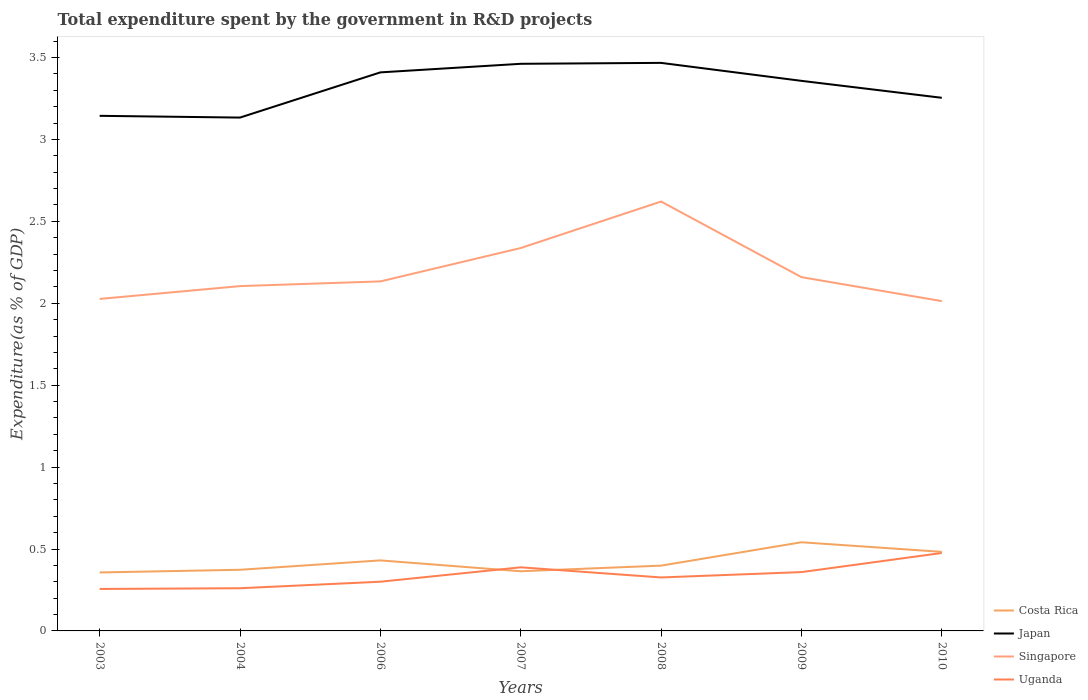How many different coloured lines are there?
Make the answer very short. 4. Does the line corresponding to Costa Rica intersect with the line corresponding to Uganda?
Provide a succinct answer. Yes. Across all years, what is the maximum total expenditure spent by the government in R&D projects in Singapore?
Your answer should be compact. 2.01. What is the total total expenditure spent by the government in R&D projects in Uganda in the graph?
Keep it short and to the point. -0.09. What is the difference between the highest and the second highest total expenditure spent by the government in R&D projects in Singapore?
Offer a very short reply. 0.61. What is the difference between the highest and the lowest total expenditure spent by the government in R&D projects in Costa Rica?
Your answer should be compact. 3. How many lines are there?
Provide a short and direct response. 4. How many years are there in the graph?
Your answer should be compact. 7. What is the difference between two consecutive major ticks on the Y-axis?
Provide a short and direct response. 0.5. Does the graph contain any zero values?
Your response must be concise. No. Where does the legend appear in the graph?
Keep it short and to the point. Bottom right. How are the legend labels stacked?
Provide a succinct answer. Vertical. What is the title of the graph?
Your answer should be very brief. Total expenditure spent by the government in R&D projects. Does "South Africa" appear as one of the legend labels in the graph?
Make the answer very short. No. What is the label or title of the X-axis?
Provide a succinct answer. Years. What is the label or title of the Y-axis?
Your response must be concise. Expenditure(as % of GDP). What is the Expenditure(as % of GDP) in Costa Rica in 2003?
Offer a very short reply. 0.36. What is the Expenditure(as % of GDP) of Japan in 2003?
Provide a succinct answer. 3.14. What is the Expenditure(as % of GDP) in Singapore in 2003?
Your answer should be compact. 2.03. What is the Expenditure(as % of GDP) in Uganda in 2003?
Your response must be concise. 0.26. What is the Expenditure(as % of GDP) in Costa Rica in 2004?
Your response must be concise. 0.37. What is the Expenditure(as % of GDP) of Japan in 2004?
Make the answer very short. 3.13. What is the Expenditure(as % of GDP) of Singapore in 2004?
Make the answer very short. 2.1. What is the Expenditure(as % of GDP) of Uganda in 2004?
Offer a terse response. 0.26. What is the Expenditure(as % of GDP) of Costa Rica in 2006?
Provide a short and direct response. 0.43. What is the Expenditure(as % of GDP) of Japan in 2006?
Offer a very short reply. 3.41. What is the Expenditure(as % of GDP) in Singapore in 2006?
Your answer should be very brief. 2.13. What is the Expenditure(as % of GDP) in Uganda in 2006?
Your response must be concise. 0.3. What is the Expenditure(as % of GDP) in Costa Rica in 2007?
Give a very brief answer. 0.36. What is the Expenditure(as % of GDP) in Japan in 2007?
Provide a succinct answer. 3.46. What is the Expenditure(as % of GDP) in Singapore in 2007?
Your answer should be compact. 2.34. What is the Expenditure(as % of GDP) of Uganda in 2007?
Your answer should be very brief. 0.39. What is the Expenditure(as % of GDP) of Costa Rica in 2008?
Keep it short and to the point. 0.4. What is the Expenditure(as % of GDP) of Japan in 2008?
Make the answer very short. 3.47. What is the Expenditure(as % of GDP) in Singapore in 2008?
Offer a terse response. 2.62. What is the Expenditure(as % of GDP) of Uganda in 2008?
Offer a terse response. 0.33. What is the Expenditure(as % of GDP) of Costa Rica in 2009?
Ensure brevity in your answer.  0.54. What is the Expenditure(as % of GDP) of Japan in 2009?
Your answer should be compact. 3.36. What is the Expenditure(as % of GDP) of Singapore in 2009?
Ensure brevity in your answer.  2.16. What is the Expenditure(as % of GDP) in Uganda in 2009?
Your answer should be compact. 0.36. What is the Expenditure(as % of GDP) in Costa Rica in 2010?
Give a very brief answer. 0.48. What is the Expenditure(as % of GDP) in Japan in 2010?
Offer a terse response. 3.25. What is the Expenditure(as % of GDP) in Singapore in 2010?
Offer a terse response. 2.01. What is the Expenditure(as % of GDP) in Uganda in 2010?
Your answer should be compact. 0.48. Across all years, what is the maximum Expenditure(as % of GDP) in Costa Rica?
Keep it short and to the point. 0.54. Across all years, what is the maximum Expenditure(as % of GDP) of Japan?
Give a very brief answer. 3.47. Across all years, what is the maximum Expenditure(as % of GDP) of Singapore?
Keep it short and to the point. 2.62. Across all years, what is the maximum Expenditure(as % of GDP) of Uganda?
Make the answer very short. 0.48. Across all years, what is the minimum Expenditure(as % of GDP) in Costa Rica?
Make the answer very short. 0.36. Across all years, what is the minimum Expenditure(as % of GDP) of Japan?
Ensure brevity in your answer.  3.13. Across all years, what is the minimum Expenditure(as % of GDP) of Singapore?
Your answer should be very brief. 2.01. Across all years, what is the minimum Expenditure(as % of GDP) in Uganda?
Provide a succinct answer. 0.26. What is the total Expenditure(as % of GDP) in Costa Rica in the graph?
Ensure brevity in your answer.  2.95. What is the total Expenditure(as % of GDP) of Japan in the graph?
Your answer should be compact. 23.23. What is the total Expenditure(as % of GDP) of Singapore in the graph?
Ensure brevity in your answer.  15.39. What is the total Expenditure(as % of GDP) of Uganda in the graph?
Your answer should be very brief. 2.37. What is the difference between the Expenditure(as % of GDP) of Costa Rica in 2003 and that in 2004?
Provide a succinct answer. -0.02. What is the difference between the Expenditure(as % of GDP) in Japan in 2003 and that in 2004?
Offer a terse response. 0.01. What is the difference between the Expenditure(as % of GDP) in Singapore in 2003 and that in 2004?
Give a very brief answer. -0.08. What is the difference between the Expenditure(as % of GDP) of Uganda in 2003 and that in 2004?
Ensure brevity in your answer.  -0. What is the difference between the Expenditure(as % of GDP) of Costa Rica in 2003 and that in 2006?
Provide a short and direct response. -0.07. What is the difference between the Expenditure(as % of GDP) of Japan in 2003 and that in 2006?
Provide a short and direct response. -0.27. What is the difference between the Expenditure(as % of GDP) of Singapore in 2003 and that in 2006?
Provide a succinct answer. -0.11. What is the difference between the Expenditure(as % of GDP) of Uganda in 2003 and that in 2006?
Make the answer very short. -0.04. What is the difference between the Expenditure(as % of GDP) of Costa Rica in 2003 and that in 2007?
Provide a short and direct response. -0.01. What is the difference between the Expenditure(as % of GDP) in Japan in 2003 and that in 2007?
Your response must be concise. -0.32. What is the difference between the Expenditure(as % of GDP) of Singapore in 2003 and that in 2007?
Your answer should be very brief. -0.31. What is the difference between the Expenditure(as % of GDP) of Uganda in 2003 and that in 2007?
Give a very brief answer. -0.13. What is the difference between the Expenditure(as % of GDP) in Costa Rica in 2003 and that in 2008?
Provide a short and direct response. -0.04. What is the difference between the Expenditure(as % of GDP) of Japan in 2003 and that in 2008?
Your answer should be very brief. -0.32. What is the difference between the Expenditure(as % of GDP) in Singapore in 2003 and that in 2008?
Your answer should be very brief. -0.59. What is the difference between the Expenditure(as % of GDP) of Uganda in 2003 and that in 2008?
Your response must be concise. -0.07. What is the difference between the Expenditure(as % of GDP) of Costa Rica in 2003 and that in 2009?
Your answer should be compact. -0.18. What is the difference between the Expenditure(as % of GDP) of Japan in 2003 and that in 2009?
Provide a succinct answer. -0.21. What is the difference between the Expenditure(as % of GDP) of Singapore in 2003 and that in 2009?
Offer a terse response. -0.13. What is the difference between the Expenditure(as % of GDP) in Uganda in 2003 and that in 2009?
Make the answer very short. -0.1. What is the difference between the Expenditure(as % of GDP) in Costa Rica in 2003 and that in 2010?
Ensure brevity in your answer.  -0.13. What is the difference between the Expenditure(as % of GDP) in Japan in 2003 and that in 2010?
Offer a terse response. -0.11. What is the difference between the Expenditure(as % of GDP) of Singapore in 2003 and that in 2010?
Ensure brevity in your answer.  0.01. What is the difference between the Expenditure(as % of GDP) of Uganda in 2003 and that in 2010?
Keep it short and to the point. -0.22. What is the difference between the Expenditure(as % of GDP) in Costa Rica in 2004 and that in 2006?
Your answer should be very brief. -0.06. What is the difference between the Expenditure(as % of GDP) in Japan in 2004 and that in 2006?
Make the answer very short. -0.28. What is the difference between the Expenditure(as % of GDP) in Singapore in 2004 and that in 2006?
Your answer should be compact. -0.03. What is the difference between the Expenditure(as % of GDP) of Uganda in 2004 and that in 2006?
Your answer should be very brief. -0.04. What is the difference between the Expenditure(as % of GDP) in Costa Rica in 2004 and that in 2007?
Keep it short and to the point. 0.01. What is the difference between the Expenditure(as % of GDP) in Japan in 2004 and that in 2007?
Your answer should be compact. -0.33. What is the difference between the Expenditure(as % of GDP) of Singapore in 2004 and that in 2007?
Ensure brevity in your answer.  -0.23. What is the difference between the Expenditure(as % of GDP) of Uganda in 2004 and that in 2007?
Keep it short and to the point. -0.13. What is the difference between the Expenditure(as % of GDP) in Costa Rica in 2004 and that in 2008?
Provide a succinct answer. -0.03. What is the difference between the Expenditure(as % of GDP) of Japan in 2004 and that in 2008?
Provide a short and direct response. -0.33. What is the difference between the Expenditure(as % of GDP) in Singapore in 2004 and that in 2008?
Your answer should be compact. -0.52. What is the difference between the Expenditure(as % of GDP) of Uganda in 2004 and that in 2008?
Give a very brief answer. -0.07. What is the difference between the Expenditure(as % of GDP) in Costa Rica in 2004 and that in 2009?
Keep it short and to the point. -0.17. What is the difference between the Expenditure(as % of GDP) of Japan in 2004 and that in 2009?
Keep it short and to the point. -0.22. What is the difference between the Expenditure(as % of GDP) in Singapore in 2004 and that in 2009?
Provide a succinct answer. -0.05. What is the difference between the Expenditure(as % of GDP) in Uganda in 2004 and that in 2009?
Your response must be concise. -0.1. What is the difference between the Expenditure(as % of GDP) in Costa Rica in 2004 and that in 2010?
Make the answer very short. -0.11. What is the difference between the Expenditure(as % of GDP) in Japan in 2004 and that in 2010?
Make the answer very short. -0.12. What is the difference between the Expenditure(as % of GDP) in Singapore in 2004 and that in 2010?
Offer a very short reply. 0.09. What is the difference between the Expenditure(as % of GDP) of Uganda in 2004 and that in 2010?
Your response must be concise. -0.22. What is the difference between the Expenditure(as % of GDP) in Costa Rica in 2006 and that in 2007?
Provide a short and direct response. 0.07. What is the difference between the Expenditure(as % of GDP) of Japan in 2006 and that in 2007?
Give a very brief answer. -0.05. What is the difference between the Expenditure(as % of GDP) of Singapore in 2006 and that in 2007?
Your answer should be very brief. -0.2. What is the difference between the Expenditure(as % of GDP) of Uganda in 2006 and that in 2007?
Your response must be concise. -0.09. What is the difference between the Expenditure(as % of GDP) of Costa Rica in 2006 and that in 2008?
Your answer should be very brief. 0.03. What is the difference between the Expenditure(as % of GDP) in Japan in 2006 and that in 2008?
Your response must be concise. -0.06. What is the difference between the Expenditure(as % of GDP) of Singapore in 2006 and that in 2008?
Your answer should be very brief. -0.49. What is the difference between the Expenditure(as % of GDP) in Uganda in 2006 and that in 2008?
Provide a short and direct response. -0.03. What is the difference between the Expenditure(as % of GDP) of Costa Rica in 2006 and that in 2009?
Keep it short and to the point. -0.11. What is the difference between the Expenditure(as % of GDP) of Japan in 2006 and that in 2009?
Your response must be concise. 0.05. What is the difference between the Expenditure(as % of GDP) in Singapore in 2006 and that in 2009?
Keep it short and to the point. -0.03. What is the difference between the Expenditure(as % of GDP) of Uganda in 2006 and that in 2009?
Your response must be concise. -0.06. What is the difference between the Expenditure(as % of GDP) in Costa Rica in 2006 and that in 2010?
Keep it short and to the point. -0.05. What is the difference between the Expenditure(as % of GDP) in Japan in 2006 and that in 2010?
Keep it short and to the point. 0.16. What is the difference between the Expenditure(as % of GDP) in Singapore in 2006 and that in 2010?
Make the answer very short. 0.12. What is the difference between the Expenditure(as % of GDP) in Uganda in 2006 and that in 2010?
Offer a terse response. -0.18. What is the difference between the Expenditure(as % of GDP) in Costa Rica in 2007 and that in 2008?
Give a very brief answer. -0.03. What is the difference between the Expenditure(as % of GDP) of Japan in 2007 and that in 2008?
Your answer should be compact. -0.01. What is the difference between the Expenditure(as % of GDP) in Singapore in 2007 and that in 2008?
Ensure brevity in your answer.  -0.28. What is the difference between the Expenditure(as % of GDP) in Uganda in 2007 and that in 2008?
Your response must be concise. 0.06. What is the difference between the Expenditure(as % of GDP) in Costa Rica in 2007 and that in 2009?
Your answer should be very brief. -0.18. What is the difference between the Expenditure(as % of GDP) of Japan in 2007 and that in 2009?
Keep it short and to the point. 0.1. What is the difference between the Expenditure(as % of GDP) in Singapore in 2007 and that in 2009?
Your response must be concise. 0.18. What is the difference between the Expenditure(as % of GDP) in Uganda in 2007 and that in 2009?
Provide a succinct answer. 0.03. What is the difference between the Expenditure(as % of GDP) in Costa Rica in 2007 and that in 2010?
Your answer should be very brief. -0.12. What is the difference between the Expenditure(as % of GDP) of Japan in 2007 and that in 2010?
Your response must be concise. 0.21. What is the difference between the Expenditure(as % of GDP) of Singapore in 2007 and that in 2010?
Your answer should be very brief. 0.32. What is the difference between the Expenditure(as % of GDP) in Uganda in 2007 and that in 2010?
Make the answer very short. -0.09. What is the difference between the Expenditure(as % of GDP) in Costa Rica in 2008 and that in 2009?
Ensure brevity in your answer.  -0.14. What is the difference between the Expenditure(as % of GDP) of Japan in 2008 and that in 2009?
Make the answer very short. 0.11. What is the difference between the Expenditure(as % of GDP) of Singapore in 2008 and that in 2009?
Offer a terse response. 0.46. What is the difference between the Expenditure(as % of GDP) of Uganda in 2008 and that in 2009?
Offer a very short reply. -0.03. What is the difference between the Expenditure(as % of GDP) in Costa Rica in 2008 and that in 2010?
Provide a succinct answer. -0.08. What is the difference between the Expenditure(as % of GDP) of Japan in 2008 and that in 2010?
Offer a terse response. 0.21. What is the difference between the Expenditure(as % of GDP) of Singapore in 2008 and that in 2010?
Make the answer very short. 0.61. What is the difference between the Expenditure(as % of GDP) of Uganda in 2008 and that in 2010?
Your answer should be compact. -0.15. What is the difference between the Expenditure(as % of GDP) of Costa Rica in 2009 and that in 2010?
Make the answer very short. 0.06. What is the difference between the Expenditure(as % of GDP) in Japan in 2009 and that in 2010?
Offer a very short reply. 0.1. What is the difference between the Expenditure(as % of GDP) of Singapore in 2009 and that in 2010?
Offer a terse response. 0.15. What is the difference between the Expenditure(as % of GDP) of Uganda in 2009 and that in 2010?
Provide a succinct answer. -0.12. What is the difference between the Expenditure(as % of GDP) in Costa Rica in 2003 and the Expenditure(as % of GDP) in Japan in 2004?
Your answer should be compact. -2.78. What is the difference between the Expenditure(as % of GDP) in Costa Rica in 2003 and the Expenditure(as % of GDP) in Singapore in 2004?
Provide a short and direct response. -1.75. What is the difference between the Expenditure(as % of GDP) in Costa Rica in 2003 and the Expenditure(as % of GDP) in Uganda in 2004?
Your response must be concise. 0.1. What is the difference between the Expenditure(as % of GDP) in Japan in 2003 and the Expenditure(as % of GDP) in Singapore in 2004?
Give a very brief answer. 1.04. What is the difference between the Expenditure(as % of GDP) of Japan in 2003 and the Expenditure(as % of GDP) of Uganda in 2004?
Provide a short and direct response. 2.88. What is the difference between the Expenditure(as % of GDP) in Singapore in 2003 and the Expenditure(as % of GDP) in Uganda in 2004?
Give a very brief answer. 1.77. What is the difference between the Expenditure(as % of GDP) of Costa Rica in 2003 and the Expenditure(as % of GDP) of Japan in 2006?
Your response must be concise. -3.05. What is the difference between the Expenditure(as % of GDP) of Costa Rica in 2003 and the Expenditure(as % of GDP) of Singapore in 2006?
Your response must be concise. -1.78. What is the difference between the Expenditure(as % of GDP) of Costa Rica in 2003 and the Expenditure(as % of GDP) of Uganda in 2006?
Your answer should be very brief. 0.06. What is the difference between the Expenditure(as % of GDP) in Japan in 2003 and the Expenditure(as % of GDP) in Singapore in 2006?
Keep it short and to the point. 1.01. What is the difference between the Expenditure(as % of GDP) of Japan in 2003 and the Expenditure(as % of GDP) of Uganda in 2006?
Keep it short and to the point. 2.84. What is the difference between the Expenditure(as % of GDP) in Singapore in 2003 and the Expenditure(as % of GDP) in Uganda in 2006?
Your response must be concise. 1.73. What is the difference between the Expenditure(as % of GDP) in Costa Rica in 2003 and the Expenditure(as % of GDP) in Japan in 2007?
Keep it short and to the point. -3.1. What is the difference between the Expenditure(as % of GDP) in Costa Rica in 2003 and the Expenditure(as % of GDP) in Singapore in 2007?
Offer a terse response. -1.98. What is the difference between the Expenditure(as % of GDP) of Costa Rica in 2003 and the Expenditure(as % of GDP) of Uganda in 2007?
Keep it short and to the point. -0.03. What is the difference between the Expenditure(as % of GDP) in Japan in 2003 and the Expenditure(as % of GDP) in Singapore in 2007?
Offer a terse response. 0.81. What is the difference between the Expenditure(as % of GDP) in Japan in 2003 and the Expenditure(as % of GDP) in Uganda in 2007?
Make the answer very short. 2.76. What is the difference between the Expenditure(as % of GDP) of Singapore in 2003 and the Expenditure(as % of GDP) of Uganda in 2007?
Your response must be concise. 1.64. What is the difference between the Expenditure(as % of GDP) of Costa Rica in 2003 and the Expenditure(as % of GDP) of Japan in 2008?
Your answer should be very brief. -3.11. What is the difference between the Expenditure(as % of GDP) in Costa Rica in 2003 and the Expenditure(as % of GDP) in Singapore in 2008?
Provide a short and direct response. -2.26. What is the difference between the Expenditure(as % of GDP) of Costa Rica in 2003 and the Expenditure(as % of GDP) of Uganda in 2008?
Ensure brevity in your answer.  0.03. What is the difference between the Expenditure(as % of GDP) of Japan in 2003 and the Expenditure(as % of GDP) of Singapore in 2008?
Keep it short and to the point. 0.52. What is the difference between the Expenditure(as % of GDP) of Japan in 2003 and the Expenditure(as % of GDP) of Uganda in 2008?
Keep it short and to the point. 2.82. What is the difference between the Expenditure(as % of GDP) of Costa Rica in 2003 and the Expenditure(as % of GDP) of Japan in 2009?
Ensure brevity in your answer.  -3. What is the difference between the Expenditure(as % of GDP) of Costa Rica in 2003 and the Expenditure(as % of GDP) of Singapore in 2009?
Offer a terse response. -1.8. What is the difference between the Expenditure(as % of GDP) of Costa Rica in 2003 and the Expenditure(as % of GDP) of Uganda in 2009?
Offer a terse response. -0. What is the difference between the Expenditure(as % of GDP) of Japan in 2003 and the Expenditure(as % of GDP) of Singapore in 2009?
Your response must be concise. 0.98. What is the difference between the Expenditure(as % of GDP) in Japan in 2003 and the Expenditure(as % of GDP) in Uganda in 2009?
Make the answer very short. 2.78. What is the difference between the Expenditure(as % of GDP) of Singapore in 2003 and the Expenditure(as % of GDP) of Uganda in 2009?
Offer a very short reply. 1.67. What is the difference between the Expenditure(as % of GDP) of Costa Rica in 2003 and the Expenditure(as % of GDP) of Japan in 2010?
Your answer should be compact. -2.9. What is the difference between the Expenditure(as % of GDP) of Costa Rica in 2003 and the Expenditure(as % of GDP) of Singapore in 2010?
Give a very brief answer. -1.66. What is the difference between the Expenditure(as % of GDP) in Costa Rica in 2003 and the Expenditure(as % of GDP) in Uganda in 2010?
Provide a short and direct response. -0.12. What is the difference between the Expenditure(as % of GDP) of Japan in 2003 and the Expenditure(as % of GDP) of Singapore in 2010?
Provide a succinct answer. 1.13. What is the difference between the Expenditure(as % of GDP) in Japan in 2003 and the Expenditure(as % of GDP) in Uganda in 2010?
Your response must be concise. 2.67. What is the difference between the Expenditure(as % of GDP) in Singapore in 2003 and the Expenditure(as % of GDP) in Uganda in 2010?
Your response must be concise. 1.55. What is the difference between the Expenditure(as % of GDP) in Costa Rica in 2004 and the Expenditure(as % of GDP) in Japan in 2006?
Provide a succinct answer. -3.04. What is the difference between the Expenditure(as % of GDP) in Costa Rica in 2004 and the Expenditure(as % of GDP) in Singapore in 2006?
Provide a short and direct response. -1.76. What is the difference between the Expenditure(as % of GDP) in Costa Rica in 2004 and the Expenditure(as % of GDP) in Uganda in 2006?
Offer a terse response. 0.07. What is the difference between the Expenditure(as % of GDP) in Japan in 2004 and the Expenditure(as % of GDP) in Uganda in 2006?
Your answer should be compact. 2.83. What is the difference between the Expenditure(as % of GDP) of Singapore in 2004 and the Expenditure(as % of GDP) of Uganda in 2006?
Your response must be concise. 1.8. What is the difference between the Expenditure(as % of GDP) of Costa Rica in 2004 and the Expenditure(as % of GDP) of Japan in 2007?
Ensure brevity in your answer.  -3.09. What is the difference between the Expenditure(as % of GDP) in Costa Rica in 2004 and the Expenditure(as % of GDP) in Singapore in 2007?
Give a very brief answer. -1.96. What is the difference between the Expenditure(as % of GDP) in Costa Rica in 2004 and the Expenditure(as % of GDP) in Uganda in 2007?
Provide a short and direct response. -0.01. What is the difference between the Expenditure(as % of GDP) of Japan in 2004 and the Expenditure(as % of GDP) of Singapore in 2007?
Your answer should be very brief. 0.8. What is the difference between the Expenditure(as % of GDP) in Japan in 2004 and the Expenditure(as % of GDP) in Uganda in 2007?
Provide a succinct answer. 2.75. What is the difference between the Expenditure(as % of GDP) of Singapore in 2004 and the Expenditure(as % of GDP) of Uganda in 2007?
Offer a terse response. 1.72. What is the difference between the Expenditure(as % of GDP) of Costa Rica in 2004 and the Expenditure(as % of GDP) of Japan in 2008?
Ensure brevity in your answer.  -3.09. What is the difference between the Expenditure(as % of GDP) in Costa Rica in 2004 and the Expenditure(as % of GDP) in Singapore in 2008?
Offer a terse response. -2.25. What is the difference between the Expenditure(as % of GDP) in Costa Rica in 2004 and the Expenditure(as % of GDP) in Uganda in 2008?
Provide a succinct answer. 0.05. What is the difference between the Expenditure(as % of GDP) in Japan in 2004 and the Expenditure(as % of GDP) in Singapore in 2008?
Make the answer very short. 0.51. What is the difference between the Expenditure(as % of GDP) of Japan in 2004 and the Expenditure(as % of GDP) of Uganda in 2008?
Your response must be concise. 2.81. What is the difference between the Expenditure(as % of GDP) in Singapore in 2004 and the Expenditure(as % of GDP) in Uganda in 2008?
Your answer should be very brief. 1.78. What is the difference between the Expenditure(as % of GDP) in Costa Rica in 2004 and the Expenditure(as % of GDP) in Japan in 2009?
Your answer should be compact. -2.98. What is the difference between the Expenditure(as % of GDP) of Costa Rica in 2004 and the Expenditure(as % of GDP) of Singapore in 2009?
Provide a short and direct response. -1.79. What is the difference between the Expenditure(as % of GDP) in Costa Rica in 2004 and the Expenditure(as % of GDP) in Uganda in 2009?
Offer a terse response. 0.01. What is the difference between the Expenditure(as % of GDP) of Japan in 2004 and the Expenditure(as % of GDP) of Singapore in 2009?
Provide a succinct answer. 0.97. What is the difference between the Expenditure(as % of GDP) in Japan in 2004 and the Expenditure(as % of GDP) in Uganda in 2009?
Give a very brief answer. 2.77. What is the difference between the Expenditure(as % of GDP) in Singapore in 2004 and the Expenditure(as % of GDP) in Uganda in 2009?
Keep it short and to the point. 1.75. What is the difference between the Expenditure(as % of GDP) of Costa Rica in 2004 and the Expenditure(as % of GDP) of Japan in 2010?
Your response must be concise. -2.88. What is the difference between the Expenditure(as % of GDP) in Costa Rica in 2004 and the Expenditure(as % of GDP) in Singapore in 2010?
Keep it short and to the point. -1.64. What is the difference between the Expenditure(as % of GDP) in Costa Rica in 2004 and the Expenditure(as % of GDP) in Uganda in 2010?
Offer a terse response. -0.1. What is the difference between the Expenditure(as % of GDP) in Japan in 2004 and the Expenditure(as % of GDP) in Singapore in 2010?
Keep it short and to the point. 1.12. What is the difference between the Expenditure(as % of GDP) of Japan in 2004 and the Expenditure(as % of GDP) of Uganda in 2010?
Provide a succinct answer. 2.66. What is the difference between the Expenditure(as % of GDP) of Singapore in 2004 and the Expenditure(as % of GDP) of Uganda in 2010?
Provide a short and direct response. 1.63. What is the difference between the Expenditure(as % of GDP) in Costa Rica in 2006 and the Expenditure(as % of GDP) in Japan in 2007?
Provide a succinct answer. -3.03. What is the difference between the Expenditure(as % of GDP) in Costa Rica in 2006 and the Expenditure(as % of GDP) in Singapore in 2007?
Offer a very short reply. -1.91. What is the difference between the Expenditure(as % of GDP) of Costa Rica in 2006 and the Expenditure(as % of GDP) of Uganda in 2007?
Provide a short and direct response. 0.04. What is the difference between the Expenditure(as % of GDP) of Japan in 2006 and the Expenditure(as % of GDP) of Singapore in 2007?
Provide a succinct answer. 1.07. What is the difference between the Expenditure(as % of GDP) in Japan in 2006 and the Expenditure(as % of GDP) in Uganda in 2007?
Offer a terse response. 3.02. What is the difference between the Expenditure(as % of GDP) in Singapore in 2006 and the Expenditure(as % of GDP) in Uganda in 2007?
Give a very brief answer. 1.75. What is the difference between the Expenditure(as % of GDP) of Costa Rica in 2006 and the Expenditure(as % of GDP) of Japan in 2008?
Offer a very short reply. -3.04. What is the difference between the Expenditure(as % of GDP) in Costa Rica in 2006 and the Expenditure(as % of GDP) in Singapore in 2008?
Give a very brief answer. -2.19. What is the difference between the Expenditure(as % of GDP) in Costa Rica in 2006 and the Expenditure(as % of GDP) in Uganda in 2008?
Keep it short and to the point. 0.1. What is the difference between the Expenditure(as % of GDP) in Japan in 2006 and the Expenditure(as % of GDP) in Singapore in 2008?
Ensure brevity in your answer.  0.79. What is the difference between the Expenditure(as % of GDP) in Japan in 2006 and the Expenditure(as % of GDP) in Uganda in 2008?
Offer a terse response. 3.08. What is the difference between the Expenditure(as % of GDP) in Singapore in 2006 and the Expenditure(as % of GDP) in Uganda in 2008?
Give a very brief answer. 1.81. What is the difference between the Expenditure(as % of GDP) in Costa Rica in 2006 and the Expenditure(as % of GDP) in Japan in 2009?
Give a very brief answer. -2.93. What is the difference between the Expenditure(as % of GDP) of Costa Rica in 2006 and the Expenditure(as % of GDP) of Singapore in 2009?
Provide a succinct answer. -1.73. What is the difference between the Expenditure(as % of GDP) of Costa Rica in 2006 and the Expenditure(as % of GDP) of Uganda in 2009?
Provide a short and direct response. 0.07. What is the difference between the Expenditure(as % of GDP) in Japan in 2006 and the Expenditure(as % of GDP) in Singapore in 2009?
Make the answer very short. 1.25. What is the difference between the Expenditure(as % of GDP) of Japan in 2006 and the Expenditure(as % of GDP) of Uganda in 2009?
Your response must be concise. 3.05. What is the difference between the Expenditure(as % of GDP) in Singapore in 2006 and the Expenditure(as % of GDP) in Uganda in 2009?
Give a very brief answer. 1.77. What is the difference between the Expenditure(as % of GDP) in Costa Rica in 2006 and the Expenditure(as % of GDP) in Japan in 2010?
Your answer should be compact. -2.82. What is the difference between the Expenditure(as % of GDP) in Costa Rica in 2006 and the Expenditure(as % of GDP) in Singapore in 2010?
Your answer should be compact. -1.58. What is the difference between the Expenditure(as % of GDP) in Costa Rica in 2006 and the Expenditure(as % of GDP) in Uganda in 2010?
Your response must be concise. -0.05. What is the difference between the Expenditure(as % of GDP) in Japan in 2006 and the Expenditure(as % of GDP) in Singapore in 2010?
Give a very brief answer. 1.4. What is the difference between the Expenditure(as % of GDP) in Japan in 2006 and the Expenditure(as % of GDP) in Uganda in 2010?
Your response must be concise. 2.93. What is the difference between the Expenditure(as % of GDP) in Singapore in 2006 and the Expenditure(as % of GDP) in Uganda in 2010?
Ensure brevity in your answer.  1.66. What is the difference between the Expenditure(as % of GDP) of Costa Rica in 2007 and the Expenditure(as % of GDP) of Japan in 2008?
Provide a short and direct response. -3.1. What is the difference between the Expenditure(as % of GDP) in Costa Rica in 2007 and the Expenditure(as % of GDP) in Singapore in 2008?
Your answer should be compact. -2.26. What is the difference between the Expenditure(as % of GDP) in Costa Rica in 2007 and the Expenditure(as % of GDP) in Uganda in 2008?
Provide a succinct answer. 0.04. What is the difference between the Expenditure(as % of GDP) in Japan in 2007 and the Expenditure(as % of GDP) in Singapore in 2008?
Offer a very short reply. 0.84. What is the difference between the Expenditure(as % of GDP) of Japan in 2007 and the Expenditure(as % of GDP) of Uganda in 2008?
Make the answer very short. 3.14. What is the difference between the Expenditure(as % of GDP) in Singapore in 2007 and the Expenditure(as % of GDP) in Uganda in 2008?
Keep it short and to the point. 2.01. What is the difference between the Expenditure(as % of GDP) in Costa Rica in 2007 and the Expenditure(as % of GDP) in Japan in 2009?
Make the answer very short. -2.99. What is the difference between the Expenditure(as % of GDP) in Costa Rica in 2007 and the Expenditure(as % of GDP) in Singapore in 2009?
Your answer should be very brief. -1.8. What is the difference between the Expenditure(as % of GDP) of Costa Rica in 2007 and the Expenditure(as % of GDP) of Uganda in 2009?
Your answer should be compact. 0.01. What is the difference between the Expenditure(as % of GDP) in Japan in 2007 and the Expenditure(as % of GDP) in Singapore in 2009?
Make the answer very short. 1.3. What is the difference between the Expenditure(as % of GDP) of Japan in 2007 and the Expenditure(as % of GDP) of Uganda in 2009?
Make the answer very short. 3.1. What is the difference between the Expenditure(as % of GDP) in Singapore in 2007 and the Expenditure(as % of GDP) in Uganda in 2009?
Provide a short and direct response. 1.98. What is the difference between the Expenditure(as % of GDP) of Costa Rica in 2007 and the Expenditure(as % of GDP) of Japan in 2010?
Give a very brief answer. -2.89. What is the difference between the Expenditure(as % of GDP) of Costa Rica in 2007 and the Expenditure(as % of GDP) of Singapore in 2010?
Offer a terse response. -1.65. What is the difference between the Expenditure(as % of GDP) in Costa Rica in 2007 and the Expenditure(as % of GDP) in Uganda in 2010?
Offer a terse response. -0.11. What is the difference between the Expenditure(as % of GDP) of Japan in 2007 and the Expenditure(as % of GDP) of Singapore in 2010?
Make the answer very short. 1.45. What is the difference between the Expenditure(as % of GDP) in Japan in 2007 and the Expenditure(as % of GDP) in Uganda in 2010?
Provide a short and direct response. 2.99. What is the difference between the Expenditure(as % of GDP) in Singapore in 2007 and the Expenditure(as % of GDP) in Uganda in 2010?
Provide a short and direct response. 1.86. What is the difference between the Expenditure(as % of GDP) in Costa Rica in 2008 and the Expenditure(as % of GDP) in Japan in 2009?
Offer a terse response. -2.96. What is the difference between the Expenditure(as % of GDP) in Costa Rica in 2008 and the Expenditure(as % of GDP) in Singapore in 2009?
Provide a succinct answer. -1.76. What is the difference between the Expenditure(as % of GDP) of Costa Rica in 2008 and the Expenditure(as % of GDP) of Uganda in 2009?
Your answer should be compact. 0.04. What is the difference between the Expenditure(as % of GDP) in Japan in 2008 and the Expenditure(as % of GDP) in Singapore in 2009?
Offer a very short reply. 1.31. What is the difference between the Expenditure(as % of GDP) of Japan in 2008 and the Expenditure(as % of GDP) of Uganda in 2009?
Provide a short and direct response. 3.11. What is the difference between the Expenditure(as % of GDP) in Singapore in 2008 and the Expenditure(as % of GDP) in Uganda in 2009?
Your response must be concise. 2.26. What is the difference between the Expenditure(as % of GDP) of Costa Rica in 2008 and the Expenditure(as % of GDP) of Japan in 2010?
Ensure brevity in your answer.  -2.86. What is the difference between the Expenditure(as % of GDP) of Costa Rica in 2008 and the Expenditure(as % of GDP) of Singapore in 2010?
Make the answer very short. -1.61. What is the difference between the Expenditure(as % of GDP) of Costa Rica in 2008 and the Expenditure(as % of GDP) of Uganda in 2010?
Provide a succinct answer. -0.08. What is the difference between the Expenditure(as % of GDP) of Japan in 2008 and the Expenditure(as % of GDP) of Singapore in 2010?
Keep it short and to the point. 1.45. What is the difference between the Expenditure(as % of GDP) of Japan in 2008 and the Expenditure(as % of GDP) of Uganda in 2010?
Ensure brevity in your answer.  2.99. What is the difference between the Expenditure(as % of GDP) of Singapore in 2008 and the Expenditure(as % of GDP) of Uganda in 2010?
Your answer should be compact. 2.15. What is the difference between the Expenditure(as % of GDP) of Costa Rica in 2009 and the Expenditure(as % of GDP) of Japan in 2010?
Provide a succinct answer. -2.71. What is the difference between the Expenditure(as % of GDP) of Costa Rica in 2009 and the Expenditure(as % of GDP) of Singapore in 2010?
Offer a very short reply. -1.47. What is the difference between the Expenditure(as % of GDP) in Costa Rica in 2009 and the Expenditure(as % of GDP) in Uganda in 2010?
Give a very brief answer. 0.07. What is the difference between the Expenditure(as % of GDP) in Japan in 2009 and the Expenditure(as % of GDP) in Singapore in 2010?
Keep it short and to the point. 1.34. What is the difference between the Expenditure(as % of GDP) of Japan in 2009 and the Expenditure(as % of GDP) of Uganda in 2010?
Offer a terse response. 2.88. What is the difference between the Expenditure(as % of GDP) in Singapore in 2009 and the Expenditure(as % of GDP) in Uganda in 2010?
Your answer should be compact. 1.68. What is the average Expenditure(as % of GDP) of Costa Rica per year?
Your answer should be compact. 0.42. What is the average Expenditure(as % of GDP) in Japan per year?
Your answer should be compact. 3.32. What is the average Expenditure(as % of GDP) in Singapore per year?
Offer a terse response. 2.2. What is the average Expenditure(as % of GDP) of Uganda per year?
Offer a terse response. 0.34. In the year 2003, what is the difference between the Expenditure(as % of GDP) of Costa Rica and Expenditure(as % of GDP) of Japan?
Make the answer very short. -2.79. In the year 2003, what is the difference between the Expenditure(as % of GDP) of Costa Rica and Expenditure(as % of GDP) of Singapore?
Provide a short and direct response. -1.67. In the year 2003, what is the difference between the Expenditure(as % of GDP) in Costa Rica and Expenditure(as % of GDP) in Uganda?
Make the answer very short. 0.1. In the year 2003, what is the difference between the Expenditure(as % of GDP) of Japan and Expenditure(as % of GDP) of Singapore?
Ensure brevity in your answer.  1.12. In the year 2003, what is the difference between the Expenditure(as % of GDP) in Japan and Expenditure(as % of GDP) in Uganda?
Provide a succinct answer. 2.89. In the year 2003, what is the difference between the Expenditure(as % of GDP) of Singapore and Expenditure(as % of GDP) of Uganda?
Your answer should be very brief. 1.77. In the year 2004, what is the difference between the Expenditure(as % of GDP) in Costa Rica and Expenditure(as % of GDP) in Japan?
Ensure brevity in your answer.  -2.76. In the year 2004, what is the difference between the Expenditure(as % of GDP) of Costa Rica and Expenditure(as % of GDP) of Singapore?
Keep it short and to the point. -1.73. In the year 2004, what is the difference between the Expenditure(as % of GDP) of Costa Rica and Expenditure(as % of GDP) of Uganda?
Offer a very short reply. 0.11. In the year 2004, what is the difference between the Expenditure(as % of GDP) of Japan and Expenditure(as % of GDP) of Singapore?
Keep it short and to the point. 1.03. In the year 2004, what is the difference between the Expenditure(as % of GDP) in Japan and Expenditure(as % of GDP) in Uganda?
Your response must be concise. 2.87. In the year 2004, what is the difference between the Expenditure(as % of GDP) of Singapore and Expenditure(as % of GDP) of Uganda?
Provide a succinct answer. 1.84. In the year 2006, what is the difference between the Expenditure(as % of GDP) of Costa Rica and Expenditure(as % of GDP) of Japan?
Your answer should be compact. -2.98. In the year 2006, what is the difference between the Expenditure(as % of GDP) of Costa Rica and Expenditure(as % of GDP) of Singapore?
Provide a short and direct response. -1.7. In the year 2006, what is the difference between the Expenditure(as % of GDP) of Costa Rica and Expenditure(as % of GDP) of Uganda?
Provide a short and direct response. 0.13. In the year 2006, what is the difference between the Expenditure(as % of GDP) in Japan and Expenditure(as % of GDP) in Singapore?
Your answer should be very brief. 1.28. In the year 2006, what is the difference between the Expenditure(as % of GDP) of Japan and Expenditure(as % of GDP) of Uganda?
Your response must be concise. 3.11. In the year 2006, what is the difference between the Expenditure(as % of GDP) in Singapore and Expenditure(as % of GDP) in Uganda?
Make the answer very short. 1.83. In the year 2007, what is the difference between the Expenditure(as % of GDP) of Costa Rica and Expenditure(as % of GDP) of Japan?
Ensure brevity in your answer.  -3.1. In the year 2007, what is the difference between the Expenditure(as % of GDP) of Costa Rica and Expenditure(as % of GDP) of Singapore?
Keep it short and to the point. -1.97. In the year 2007, what is the difference between the Expenditure(as % of GDP) of Costa Rica and Expenditure(as % of GDP) of Uganda?
Your answer should be compact. -0.02. In the year 2007, what is the difference between the Expenditure(as % of GDP) in Japan and Expenditure(as % of GDP) in Singapore?
Your answer should be compact. 1.12. In the year 2007, what is the difference between the Expenditure(as % of GDP) of Japan and Expenditure(as % of GDP) of Uganda?
Make the answer very short. 3.07. In the year 2007, what is the difference between the Expenditure(as % of GDP) in Singapore and Expenditure(as % of GDP) in Uganda?
Your response must be concise. 1.95. In the year 2008, what is the difference between the Expenditure(as % of GDP) in Costa Rica and Expenditure(as % of GDP) in Japan?
Give a very brief answer. -3.07. In the year 2008, what is the difference between the Expenditure(as % of GDP) of Costa Rica and Expenditure(as % of GDP) of Singapore?
Your answer should be very brief. -2.22. In the year 2008, what is the difference between the Expenditure(as % of GDP) of Costa Rica and Expenditure(as % of GDP) of Uganda?
Give a very brief answer. 0.07. In the year 2008, what is the difference between the Expenditure(as % of GDP) of Japan and Expenditure(as % of GDP) of Singapore?
Ensure brevity in your answer.  0.85. In the year 2008, what is the difference between the Expenditure(as % of GDP) of Japan and Expenditure(as % of GDP) of Uganda?
Offer a very short reply. 3.14. In the year 2008, what is the difference between the Expenditure(as % of GDP) in Singapore and Expenditure(as % of GDP) in Uganda?
Your response must be concise. 2.29. In the year 2009, what is the difference between the Expenditure(as % of GDP) in Costa Rica and Expenditure(as % of GDP) in Japan?
Your answer should be compact. -2.82. In the year 2009, what is the difference between the Expenditure(as % of GDP) of Costa Rica and Expenditure(as % of GDP) of Singapore?
Ensure brevity in your answer.  -1.62. In the year 2009, what is the difference between the Expenditure(as % of GDP) in Costa Rica and Expenditure(as % of GDP) in Uganda?
Give a very brief answer. 0.18. In the year 2009, what is the difference between the Expenditure(as % of GDP) in Japan and Expenditure(as % of GDP) in Singapore?
Ensure brevity in your answer.  1.2. In the year 2009, what is the difference between the Expenditure(as % of GDP) in Japan and Expenditure(as % of GDP) in Uganda?
Ensure brevity in your answer.  3. In the year 2009, what is the difference between the Expenditure(as % of GDP) in Singapore and Expenditure(as % of GDP) in Uganda?
Offer a terse response. 1.8. In the year 2010, what is the difference between the Expenditure(as % of GDP) of Costa Rica and Expenditure(as % of GDP) of Japan?
Give a very brief answer. -2.77. In the year 2010, what is the difference between the Expenditure(as % of GDP) of Costa Rica and Expenditure(as % of GDP) of Singapore?
Make the answer very short. -1.53. In the year 2010, what is the difference between the Expenditure(as % of GDP) of Costa Rica and Expenditure(as % of GDP) of Uganda?
Offer a terse response. 0.01. In the year 2010, what is the difference between the Expenditure(as % of GDP) in Japan and Expenditure(as % of GDP) in Singapore?
Offer a terse response. 1.24. In the year 2010, what is the difference between the Expenditure(as % of GDP) of Japan and Expenditure(as % of GDP) of Uganda?
Provide a succinct answer. 2.78. In the year 2010, what is the difference between the Expenditure(as % of GDP) of Singapore and Expenditure(as % of GDP) of Uganda?
Give a very brief answer. 1.54. What is the ratio of the Expenditure(as % of GDP) of Costa Rica in 2003 to that in 2004?
Offer a terse response. 0.96. What is the ratio of the Expenditure(as % of GDP) of Japan in 2003 to that in 2004?
Your answer should be compact. 1. What is the ratio of the Expenditure(as % of GDP) in Singapore in 2003 to that in 2004?
Your answer should be very brief. 0.96. What is the ratio of the Expenditure(as % of GDP) of Uganda in 2003 to that in 2004?
Offer a very short reply. 0.98. What is the ratio of the Expenditure(as % of GDP) of Costa Rica in 2003 to that in 2006?
Ensure brevity in your answer.  0.83. What is the ratio of the Expenditure(as % of GDP) in Japan in 2003 to that in 2006?
Make the answer very short. 0.92. What is the ratio of the Expenditure(as % of GDP) of Singapore in 2003 to that in 2006?
Offer a very short reply. 0.95. What is the ratio of the Expenditure(as % of GDP) of Uganda in 2003 to that in 2006?
Your answer should be compact. 0.85. What is the ratio of the Expenditure(as % of GDP) in Costa Rica in 2003 to that in 2007?
Your answer should be compact. 0.98. What is the ratio of the Expenditure(as % of GDP) in Japan in 2003 to that in 2007?
Your response must be concise. 0.91. What is the ratio of the Expenditure(as % of GDP) of Singapore in 2003 to that in 2007?
Offer a very short reply. 0.87. What is the ratio of the Expenditure(as % of GDP) of Uganda in 2003 to that in 2007?
Your response must be concise. 0.66. What is the ratio of the Expenditure(as % of GDP) of Costa Rica in 2003 to that in 2008?
Offer a very short reply. 0.9. What is the ratio of the Expenditure(as % of GDP) in Japan in 2003 to that in 2008?
Your answer should be compact. 0.91. What is the ratio of the Expenditure(as % of GDP) in Singapore in 2003 to that in 2008?
Provide a succinct answer. 0.77. What is the ratio of the Expenditure(as % of GDP) of Uganda in 2003 to that in 2008?
Offer a terse response. 0.78. What is the ratio of the Expenditure(as % of GDP) of Costa Rica in 2003 to that in 2009?
Your response must be concise. 0.66. What is the ratio of the Expenditure(as % of GDP) of Japan in 2003 to that in 2009?
Make the answer very short. 0.94. What is the ratio of the Expenditure(as % of GDP) of Singapore in 2003 to that in 2009?
Provide a short and direct response. 0.94. What is the ratio of the Expenditure(as % of GDP) of Uganda in 2003 to that in 2009?
Provide a short and direct response. 0.71. What is the ratio of the Expenditure(as % of GDP) in Costa Rica in 2003 to that in 2010?
Ensure brevity in your answer.  0.74. What is the ratio of the Expenditure(as % of GDP) in Japan in 2003 to that in 2010?
Your response must be concise. 0.97. What is the ratio of the Expenditure(as % of GDP) in Singapore in 2003 to that in 2010?
Ensure brevity in your answer.  1.01. What is the ratio of the Expenditure(as % of GDP) in Uganda in 2003 to that in 2010?
Offer a very short reply. 0.54. What is the ratio of the Expenditure(as % of GDP) in Costa Rica in 2004 to that in 2006?
Ensure brevity in your answer.  0.87. What is the ratio of the Expenditure(as % of GDP) in Japan in 2004 to that in 2006?
Offer a very short reply. 0.92. What is the ratio of the Expenditure(as % of GDP) in Singapore in 2004 to that in 2006?
Give a very brief answer. 0.99. What is the ratio of the Expenditure(as % of GDP) in Uganda in 2004 to that in 2006?
Make the answer very short. 0.87. What is the ratio of the Expenditure(as % of GDP) of Costa Rica in 2004 to that in 2007?
Provide a short and direct response. 1.02. What is the ratio of the Expenditure(as % of GDP) of Japan in 2004 to that in 2007?
Your answer should be compact. 0.91. What is the ratio of the Expenditure(as % of GDP) of Singapore in 2004 to that in 2007?
Offer a very short reply. 0.9. What is the ratio of the Expenditure(as % of GDP) of Uganda in 2004 to that in 2007?
Your response must be concise. 0.67. What is the ratio of the Expenditure(as % of GDP) of Costa Rica in 2004 to that in 2008?
Your answer should be compact. 0.94. What is the ratio of the Expenditure(as % of GDP) in Japan in 2004 to that in 2008?
Provide a succinct answer. 0.9. What is the ratio of the Expenditure(as % of GDP) of Singapore in 2004 to that in 2008?
Your response must be concise. 0.8. What is the ratio of the Expenditure(as % of GDP) in Uganda in 2004 to that in 2008?
Keep it short and to the point. 0.8. What is the ratio of the Expenditure(as % of GDP) in Costa Rica in 2004 to that in 2009?
Give a very brief answer. 0.69. What is the ratio of the Expenditure(as % of GDP) of Japan in 2004 to that in 2009?
Your answer should be very brief. 0.93. What is the ratio of the Expenditure(as % of GDP) in Singapore in 2004 to that in 2009?
Your answer should be compact. 0.97. What is the ratio of the Expenditure(as % of GDP) of Uganda in 2004 to that in 2009?
Your answer should be compact. 0.73. What is the ratio of the Expenditure(as % of GDP) of Costa Rica in 2004 to that in 2010?
Your answer should be compact. 0.77. What is the ratio of the Expenditure(as % of GDP) of Japan in 2004 to that in 2010?
Provide a succinct answer. 0.96. What is the ratio of the Expenditure(as % of GDP) of Singapore in 2004 to that in 2010?
Provide a short and direct response. 1.05. What is the ratio of the Expenditure(as % of GDP) of Uganda in 2004 to that in 2010?
Your answer should be very brief. 0.55. What is the ratio of the Expenditure(as % of GDP) in Costa Rica in 2006 to that in 2007?
Your answer should be compact. 1.18. What is the ratio of the Expenditure(as % of GDP) of Japan in 2006 to that in 2007?
Offer a very short reply. 0.98. What is the ratio of the Expenditure(as % of GDP) of Singapore in 2006 to that in 2007?
Provide a short and direct response. 0.91. What is the ratio of the Expenditure(as % of GDP) in Uganda in 2006 to that in 2007?
Offer a terse response. 0.77. What is the ratio of the Expenditure(as % of GDP) of Costa Rica in 2006 to that in 2008?
Offer a terse response. 1.08. What is the ratio of the Expenditure(as % of GDP) in Japan in 2006 to that in 2008?
Make the answer very short. 0.98. What is the ratio of the Expenditure(as % of GDP) of Singapore in 2006 to that in 2008?
Keep it short and to the point. 0.81. What is the ratio of the Expenditure(as % of GDP) of Uganda in 2006 to that in 2008?
Provide a short and direct response. 0.92. What is the ratio of the Expenditure(as % of GDP) in Costa Rica in 2006 to that in 2009?
Offer a terse response. 0.8. What is the ratio of the Expenditure(as % of GDP) in Japan in 2006 to that in 2009?
Your response must be concise. 1.02. What is the ratio of the Expenditure(as % of GDP) in Uganda in 2006 to that in 2009?
Give a very brief answer. 0.84. What is the ratio of the Expenditure(as % of GDP) of Costa Rica in 2006 to that in 2010?
Your answer should be very brief. 0.89. What is the ratio of the Expenditure(as % of GDP) of Japan in 2006 to that in 2010?
Offer a terse response. 1.05. What is the ratio of the Expenditure(as % of GDP) of Singapore in 2006 to that in 2010?
Make the answer very short. 1.06. What is the ratio of the Expenditure(as % of GDP) in Uganda in 2006 to that in 2010?
Provide a short and direct response. 0.63. What is the ratio of the Expenditure(as % of GDP) in Costa Rica in 2007 to that in 2008?
Give a very brief answer. 0.91. What is the ratio of the Expenditure(as % of GDP) of Singapore in 2007 to that in 2008?
Provide a short and direct response. 0.89. What is the ratio of the Expenditure(as % of GDP) in Uganda in 2007 to that in 2008?
Provide a succinct answer. 1.19. What is the ratio of the Expenditure(as % of GDP) of Costa Rica in 2007 to that in 2009?
Offer a very short reply. 0.67. What is the ratio of the Expenditure(as % of GDP) in Japan in 2007 to that in 2009?
Your answer should be very brief. 1.03. What is the ratio of the Expenditure(as % of GDP) of Singapore in 2007 to that in 2009?
Your answer should be compact. 1.08. What is the ratio of the Expenditure(as % of GDP) of Uganda in 2007 to that in 2009?
Your answer should be very brief. 1.08. What is the ratio of the Expenditure(as % of GDP) in Costa Rica in 2007 to that in 2010?
Ensure brevity in your answer.  0.75. What is the ratio of the Expenditure(as % of GDP) of Japan in 2007 to that in 2010?
Your answer should be very brief. 1.06. What is the ratio of the Expenditure(as % of GDP) in Singapore in 2007 to that in 2010?
Your answer should be very brief. 1.16. What is the ratio of the Expenditure(as % of GDP) in Uganda in 2007 to that in 2010?
Give a very brief answer. 0.82. What is the ratio of the Expenditure(as % of GDP) in Costa Rica in 2008 to that in 2009?
Your answer should be very brief. 0.74. What is the ratio of the Expenditure(as % of GDP) in Japan in 2008 to that in 2009?
Offer a terse response. 1.03. What is the ratio of the Expenditure(as % of GDP) of Singapore in 2008 to that in 2009?
Your answer should be very brief. 1.21. What is the ratio of the Expenditure(as % of GDP) of Uganda in 2008 to that in 2009?
Your response must be concise. 0.91. What is the ratio of the Expenditure(as % of GDP) of Costa Rica in 2008 to that in 2010?
Offer a terse response. 0.83. What is the ratio of the Expenditure(as % of GDP) in Japan in 2008 to that in 2010?
Ensure brevity in your answer.  1.07. What is the ratio of the Expenditure(as % of GDP) of Singapore in 2008 to that in 2010?
Give a very brief answer. 1.3. What is the ratio of the Expenditure(as % of GDP) of Uganda in 2008 to that in 2010?
Your answer should be compact. 0.69. What is the ratio of the Expenditure(as % of GDP) of Costa Rica in 2009 to that in 2010?
Provide a short and direct response. 1.12. What is the ratio of the Expenditure(as % of GDP) in Japan in 2009 to that in 2010?
Your answer should be very brief. 1.03. What is the ratio of the Expenditure(as % of GDP) in Singapore in 2009 to that in 2010?
Offer a very short reply. 1.07. What is the ratio of the Expenditure(as % of GDP) of Uganda in 2009 to that in 2010?
Ensure brevity in your answer.  0.75. What is the difference between the highest and the second highest Expenditure(as % of GDP) of Costa Rica?
Offer a terse response. 0.06. What is the difference between the highest and the second highest Expenditure(as % of GDP) of Japan?
Provide a succinct answer. 0.01. What is the difference between the highest and the second highest Expenditure(as % of GDP) in Singapore?
Ensure brevity in your answer.  0.28. What is the difference between the highest and the second highest Expenditure(as % of GDP) in Uganda?
Offer a terse response. 0.09. What is the difference between the highest and the lowest Expenditure(as % of GDP) of Costa Rica?
Make the answer very short. 0.18. What is the difference between the highest and the lowest Expenditure(as % of GDP) of Japan?
Offer a terse response. 0.33. What is the difference between the highest and the lowest Expenditure(as % of GDP) in Singapore?
Your answer should be compact. 0.61. What is the difference between the highest and the lowest Expenditure(as % of GDP) of Uganda?
Your answer should be very brief. 0.22. 